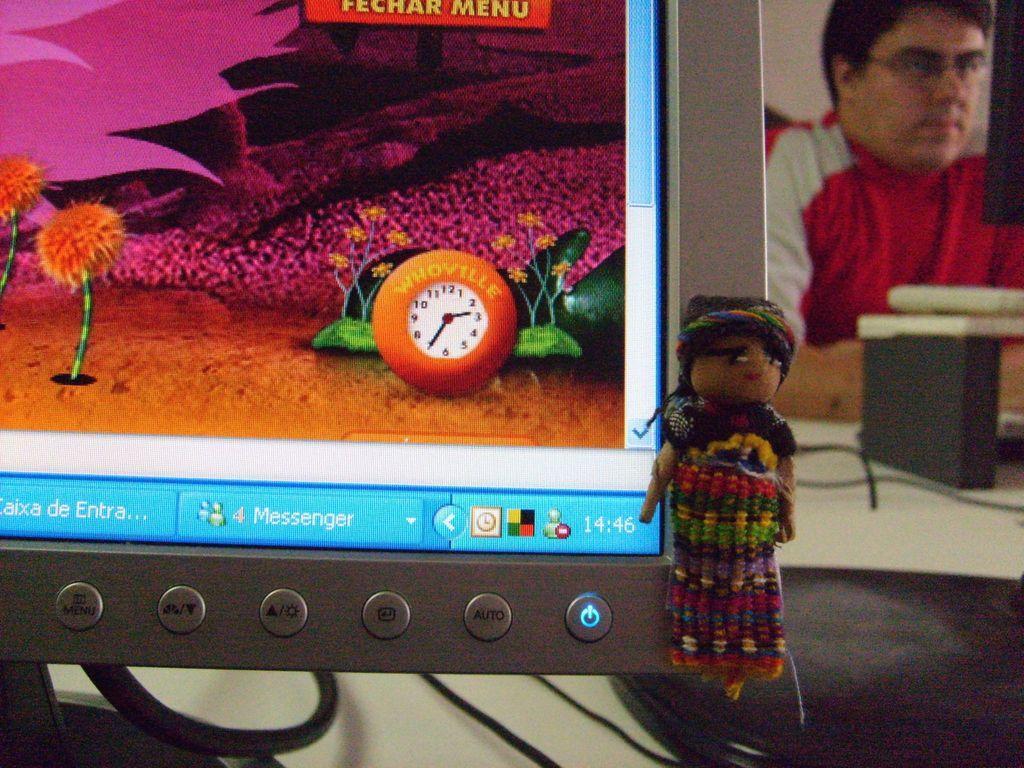In one or two sentences, can you explain what this image depicts? In this image there is a table, on that table there is a computer, behind that there is a man sitting on chair. 